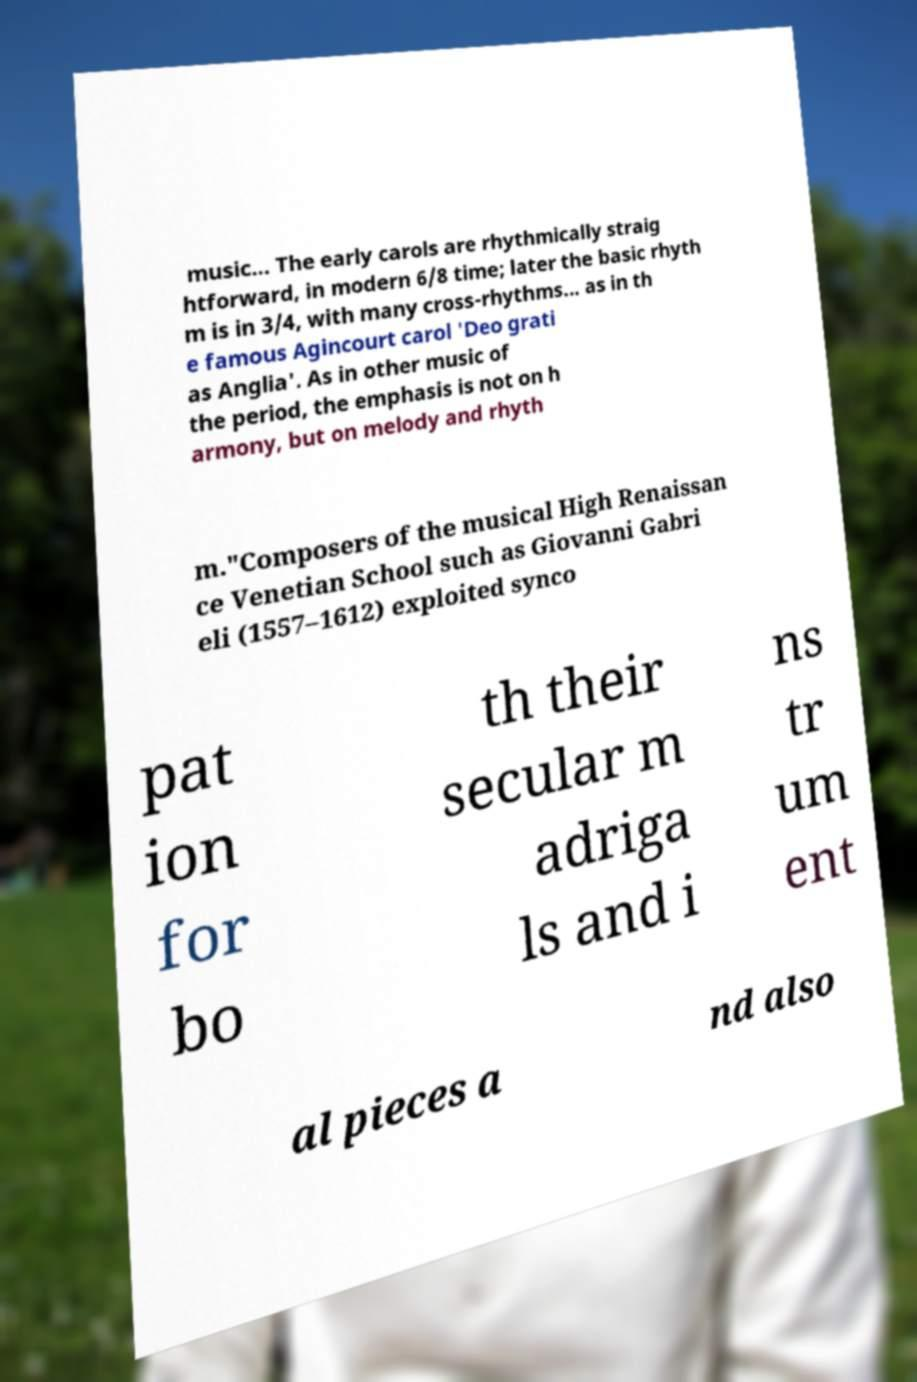Please read and relay the text visible in this image. What does it say? music... The early carols are rhythmically straig htforward, in modern 6/8 time; later the basic rhyth m is in 3/4, with many cross-rhythms... as in th e famous Agincourt carol 'Deo grati as Anglia'. As in other music of the period, the emphasis is not on h armony, but on melody and rhyth m."Composers of the musical High Renaissan ce Venetian School such as Giovanni Gabri eli (1557–1612) exploited synco pat ion for bo th their secular m adriga ls and i ns tr um ent al pieces a nd also 